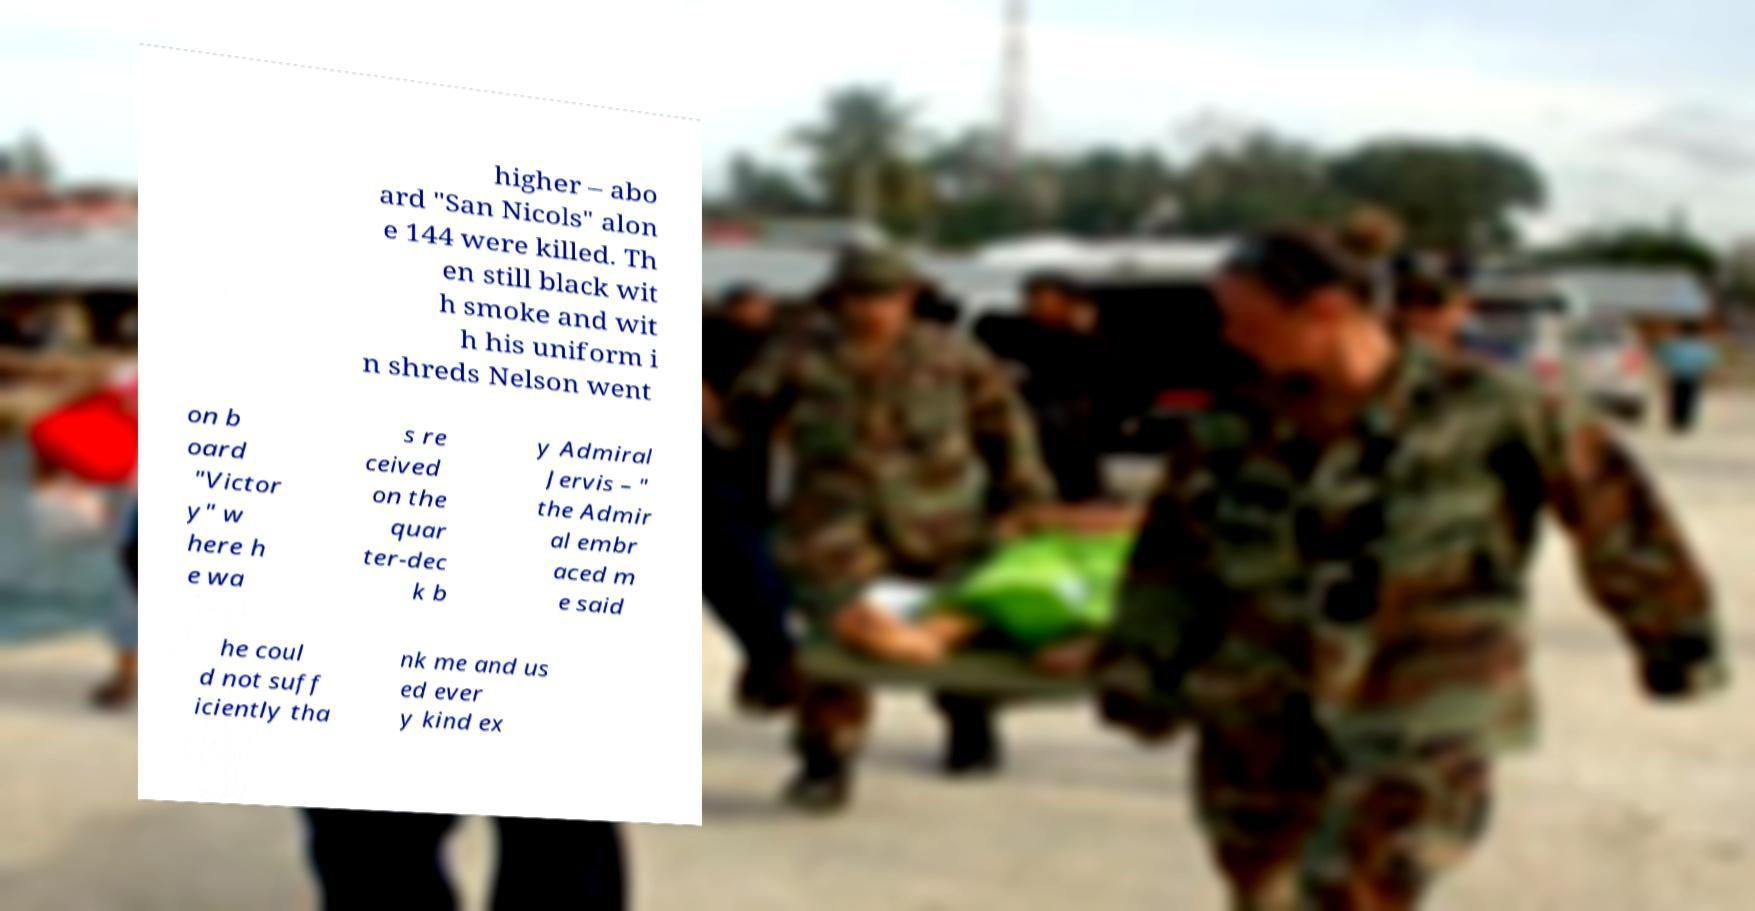Can you accurately transcribe the text from the provided image for me? higher – abo ard "San Nicols" alon e 144 were killed. Th en still black wit h smoke and wit h his uniform i n shreds Nelson went on b oard "Victor y" w here h e wa s re ceived on the quar ter-dec k b y Admiral Jervis – " the Admir al embr aced m e said he coul d not suff iciently tha nk me and us ed ever y kind ex 